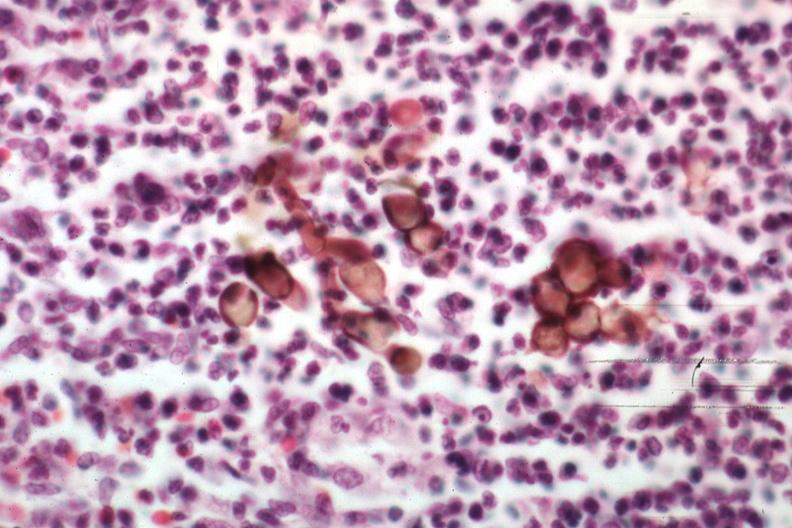where is this?
Answer the question using a single word or phrase. Skin 